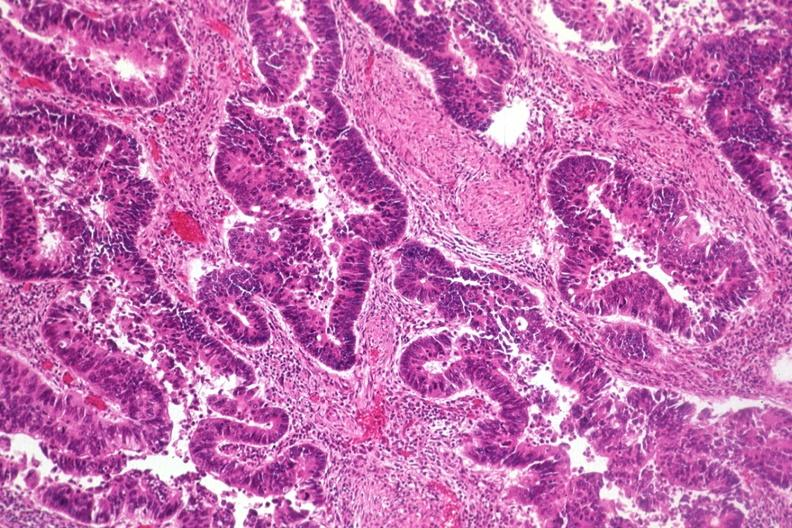what does this image show?
Answer the question using a single word or phrase. Typical histology for colon adenocarcinoma 